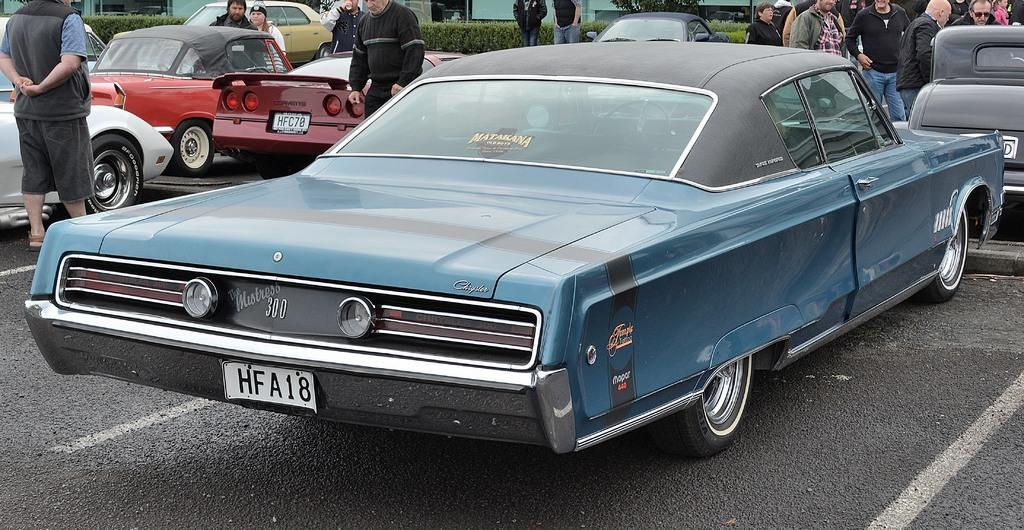What is the main subject in the center of the image? There are cars in the center of the image. Can you describe the people present in the image? There are people present in the image. What type of surface can be seen at the bottom of the image? There is a road at the bottom of the image. What type of vegetation is visible at the top of the image? Bushes and plants are visible at the top of the image. What type of sail can be seen on the building in the image? There is no building or sail present in the image. How do the people in the image express disgust? The image does not show any expressions of disgust by the people present. 